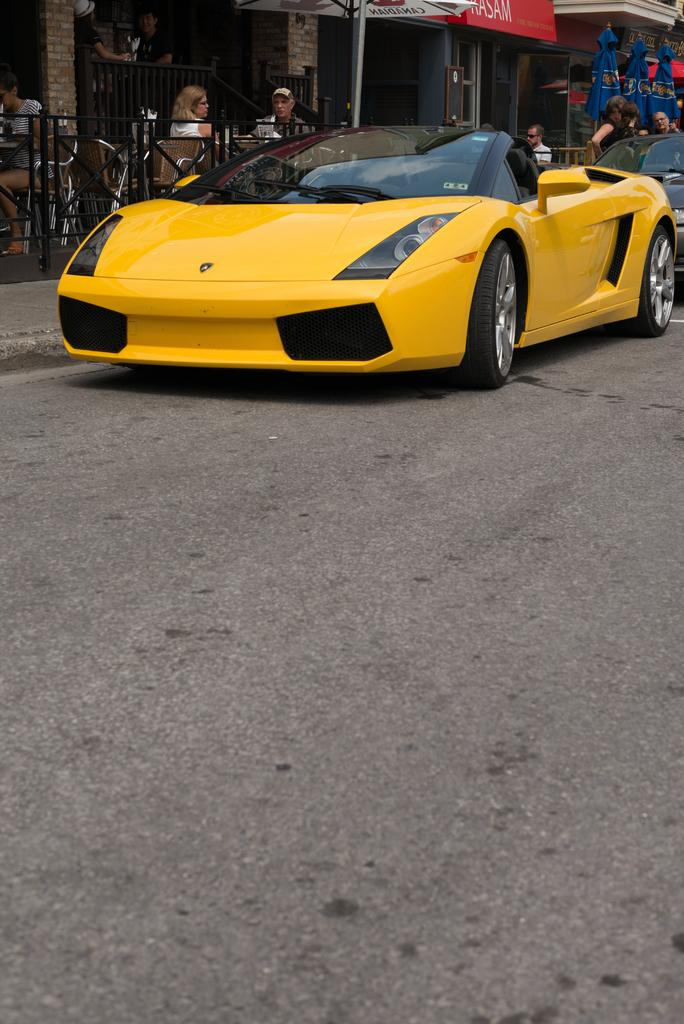What type of vehicles can be seen on the road in the image? There are cars on the road in the image. What structures are visible in the background of the image? There are buildings visible in the image. What object is being used for shade or protection from the elements in the image? There is an umbrella in the image. What are the people in the image doing? There are people seated on chairs in the image. What decorative or symbolic items can be seen in the image? There are flags in the image. What is the purpose of the kick in the image? There is no kick present in the image. How does the stop affect the movement of the cars in the image? There is no stop mentioned in the image, so we cannot determine its effect on the cars. 